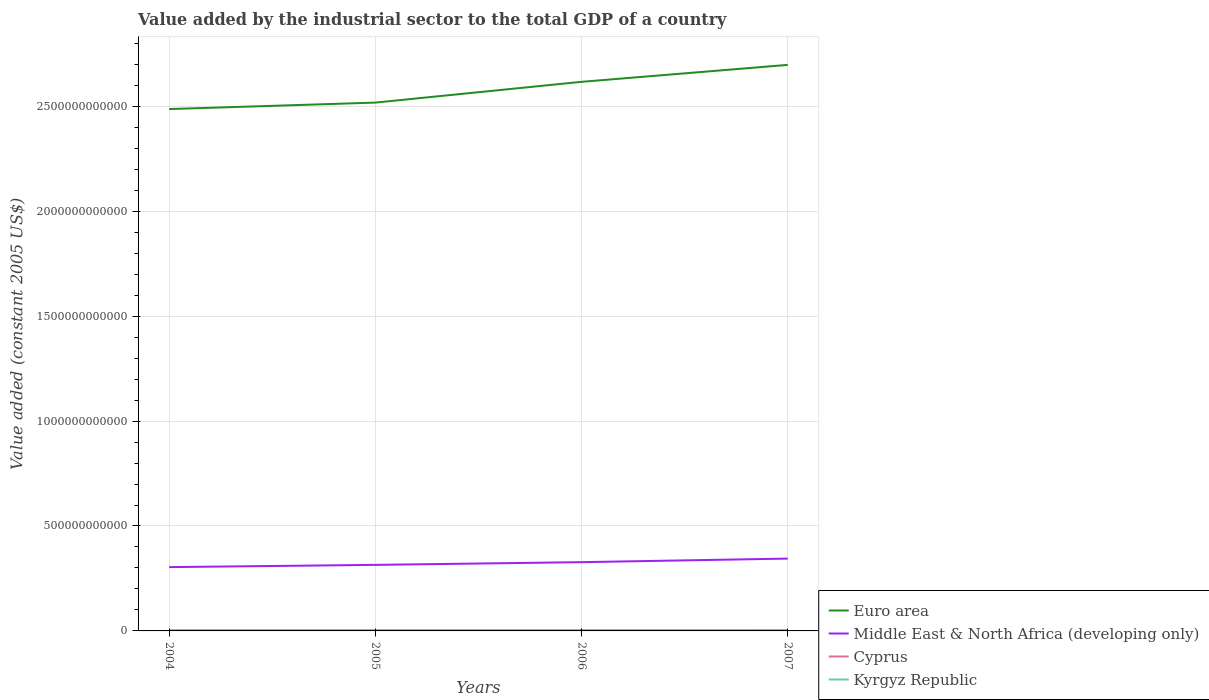Does the line corresponding to Cyprus intersect with the line corresponding to Middle East & North Africa (developing only)?
Your response must be concise. No. Across all years, what is the maximum value added by the industrial sector in Cyprus?
Give a very brief answer. 3.28e+09. What is the total value added by the industrial sector in Kyrgyz Republic in the graph?
Your response must be concise. 8.83e+07. What is the difference between the highest and the second highest value added by the industrial sector in Euro area?
Your answer should be compact. 2.11e+11. What is the difference between the highest and the lowest value added by the industrial sector in Cyprus?
Provide a succinct answer. 2. Is the value added by the industrial sector in Euro area strictly greater than the value added by the industrial sector in Kyrgyz Republic over the years?
Provide a short and direct response. No. How many years are there in the graph?
Ensure brevity in your answer.  4. What is the difference between two consecutive major ticks on the Y-axis?
Offer a terse response. 5.00e+11. Are the values on the major ticks of Y-axis written in scientific E-notation?
Offer a terse response. No. What is the title of the graph?
Provide a succinct answer. Value added by the industrial sector to the total GDP of a country. What is the label or title of the X-axis?
Make the answer very short. Years. What is the label or title of the Y-axis?
Ensure brevity in your answer.  Value added (constant 2005 US$). What is the Value added (constant 2005 US$) of Euro area in 2004?
Offer a terse response. 2.49e+12. What is the Value added (constant 2005 US$) in Middle East & North Africa (developing only) in 2004?
Your response must be concise. 3.04e+11. What is the Value added (constant 2005 US$) of Cyprus in 2004?
Keep it short and to the point. 3.28e+09. What is the Value added (constant 2005 US$) of Kyrgyz Republic in 2004?
Your answer should be very brief. 5.45e+08. What is the Value added (constant 2005 US$) of Euro area in 2005?
Provide a short and direct response. 2.52e+12. What is the Value added (constant 2005 US$) of Middle East & North Africa (developing only) in 2005?
Keep it short and to the point. 3.15e+11. What is the Value added (constant 2005 US$) of Cyprus in 2005?
Make the answer very short. 3.34e+09. What is the Value added (constant 2005 US$) in Kyrgyz Republic in 2005?
Your response must be concise. 4.91e+08. What is the Value added (constant 2005 US$) of Euro area in 2006?
Offer a terse response. 2.62e+12. What is the Value added (constant 2005 US$) of Middle East & North Africa (developing only) in 2006?
Provide a succinct answer. 3.28e+11. What is the Value added (constant 2005 US$) in Cyprus in 2006?
Provide a succinct answer. 3.45e+09. What is the Value added (constant 2005 US$) of Kyrgyz Republic in 2006?
Offer a very short reply. 4.57e+08. What is the Value added (constant 2005 US$) in Euro area in 2007?
Offer a terse response. 2.70e+12. What is the Value added (constant 2005 US$) in Middle East & North Africa (developing only) in 2007?
Your answer should be compact. 3.45e+11. What is the Value added (constant 2005 US$) in Cyprus in 2007?
Offer a very short reply. 3.65e+09. What is the Value added (constant 2005 US$) of Kyrgyz Republic in 2007?
Your response must be concise. 5.04e+08. Across all years, what is the maximum Value added (constant 2005 US$) in Euro area?
Provide a short and direct response. 2.70e+12. Across all years, what is the maximum Value added (constant 2005 US$) of Middle East & North Africa (developing only)?
Give a very brief answer. 3.45e+11. Across all years, what is the maximum Value added (constant 2005 US$) of Cyprus?
Offer a terse response. 3.65e+09. Across all years, what is the maximum Value added (constant 2005 US$) in Kyrgyz Republic?
Your answer should be compact. 5.45e+08. Across all years, what is the minimum Value added (constant 2005 US$) in Euro area?
Your response must be concise. 2.49e+12. Across all years, what is the minimum Value added (constant 2005 US$) of Middle East & North Africa (developing only)?
Ensure brevity in your answer.  3.04e+11. Across all years, what is the minimum Value added (constant 2005 US$) in Cyprus?
Make the answer very short. 3.28e+09. Across all years, what is the minimum Value added (constant 2005 US$) in Kyrgyz Republic?
Offer a very short reply. 4.57e+08. What is the total Value added (constant 2005 US$) of Euro area in the graph?
Make the answer very short. 1.03e+13. What is the total Value added (constant 2005 US$) of Middle East & North Africa (developing only) in the graph?
Keep it short and to the point. 1.29e+12. What is the total Value added (constant 2005 US$) of Cyprus in the graph?
Keep it short and to the point. 1.37e+1. What is the total Value added (constant 2005 US$) of Kyrgyz Republic in the graph?
Make the answer very short. 2.00e+09. What is the difference between the Value added (constant 2005 US$) of Euro area in 2004 and that in 2005?
Ensure brevity in your answer.  -3.10e+1. What is the difference between the Value added (constant 2005 US$) in Middle East & North Africa (developing only) in 2004 and that in 2005?
Provide a short and direct response. -1.07e+1. What is the difference between the Value added (constant 2005 US$) in Cyprus in 2004 and that in 2005?
Make the answer very short. -5.62e+07. What is the difference between the Value added (constant 2005 US$) of Kyrgyz Republic in 2004 and that in 2005?
Offer a terse response. 5.37e+07. What is the difference between the Value added (constant 2005 US$) of Euro area in 2004 and that in 2006?
Offer a very short reply. -1.30e+11. What is the difference between the Value added (constant 2005 US$) in Middle East & North Africa (developing only) in 2004 and that in 2006?
Provide a short and direct response. -2.36e+1. What is the difference between the Value added (constant 2005 US$) of Cyprus in 2004 and that in 2006?
Your answer should be very brief. -1.70e+08. What is the difference between the Value added (constant 2005 US$) in Kyrgyz Republic in 2004 and that in 2006?
Provide a succinct answer. 8.83e+07. What is the difference between the Value added (constant 2005 US$) in Euro area in 2004 and that in 2007?
Offer a terse response. -2.11e+11. What is the difference between the Value added (constant 2005 US$) in Middle East & North Africa (developing only) in 2004 and that in 2007?
Your answer should be compact. -4.06e+1. What is the difference between the Value added (constant 2005 US$) in Cyprus in 2004 and that in 2007?
Give a very brief answer. -3.75e+08. What is the difference between the Value added (constant 2005 US$) in Kyrgyz Republic in 2004 and that in 2007?
Keep it short and to the point. 4.13e+07. What is the difference between the Value added (constant 2005 US$) of Euro area in 2005 and that in 2006?
Your response must be concise. -9.90e+1. What is the difference between the Value added (constant 2005 US$) of Middle East & North Africa (developing only) in 2005 and that in 2006?
Offer a terse response. -1.30e+1. What is the difference between the Value added (constant 2005 US$) in Cyprus in 2005 and that in 2006?
Your answer should be compact. -1.14e+08. What is the difference between the Value added (constant 2005 US$) of Kyrgyz Republic in 2005 and that in 2006?
Provide a succinct answer. 3.46e+07. What is the difference between the Value added (constant 2005 US$) in Euro area in 2005 and that in 2007?
Provide a succinct answer. -1.80e+11. What is the difference between the Value added (constant 2005 US$) of Middle East & North Africa (developing only) in 2005 and that in 2007?
Your response must be concise. -2.99e+1. What is the difference between the Value added (constant 2005 US$) of Cyprus in 2005 and that in 2007?
Provide a succinct answer. -3.19e+08. What is the difference between the Value added (constant 2005 US$) of Kyrgyz Republic in 2005 and that in 2007?
Your answer should be compact. -1.24e+07. What is the difference between the Value added (constant 2005 US$) of Euro area in 2006 and that in 2007?
Your answer should be very brief. -8.08e+1. What is the difference between the Value added (constant 2005 US$) in Middle East & North Africa (developing only) in 2006 and that in 2007?
Give a very brief answer. -1.70e+1. What is the difference between the Value added (constant 2005 US$) in Cyprus in 2006 and that in 2007?
Offer a very short reply. -2.05e+08. What is the difference between the Value added (constant 2005 US$) in Kyrgyz Republic in 2006 and that in 2007?
Make the answer very short. -4.70e+07. What is the difference between the Value added (constant 2005 US$) of Euro area in 2004 and the Value added (constant 2005 US$) of Middle East & North Africa (developing only) in 2005?
Your response must be concise. 2.17e+12. What is the difference between the Value added (constant 2005 US$) in Euro area in 2004 and the Value added (constant 2005 US$) in Cyprus in 2005?
Ensure brevity in your answer.  2.48e+12. What is the difference between the Value added (constant 2005 US$) in Euro area in 2004 and the Value added (constant 2005 US$) in Kyrgyz Republic in 2005?
Offer a very short reply. 2.49e+12. What is the difference between the Value added (constant 2005 US$) of Middle East & North Africa (developing only) in 2004 and the Value added (constant 2005 US$) of Cyprus in 2005?
Your response must be concise. 3.01e+11. What is the difference between the Value added (constant 2005 US$) in Middle East & North Africa (developing only) in 2004 and the Value added (constant 2005 US$) in Kyrgyz Republic in 2005?
Your answer should be compact. 3.04e+11. What is the difference between the Value added (constant 2005 US$) of Cyprus in 2004 and the Value added (constant 2005 US$) of Kyrgyz Republic in 2005?
Provide a short and direct response. 2.79e+09. What is the difference between the Value added (constant 2005 US$) of Euro area in 2004 and the Value added (constant 2005 US$) of Middle East & North Africa (developing only) in 2006?
Offer a terse response. 2.16e+12. What is the difference between the Value added (constant 2005 US$) in Euro area in 2004 and the Value added (constant 2005 US$) in Cyprus in 2006?
Make the answer very short. 2.48e+12. What is the difference between the Value added (constant 2005 US$) of Euro area in 2004 and the Value added (constant 2005 US$) of Kyrgyz Republic in 2006?
Your answer should be very brief. 2.49e+12. What is the difference between the Value added (constant 2005 US$) of Middle East & North Africa (developing only) in 2004 and the Value added (constant 2005 US$) of Cyprus in 2006?
Provide a succinct answer. 3.01e+11. What is the difference between the Value added (constant 2005 US$) of Middle East & North Africa (developing only) in 2004 and the Value added (constant 2005 US$) of Kyrgyz Republic in 2006?
Offer a terse response. 3.04e+11. What is the difference between the Value added (constant 2005 US$) in Cyprus in 2004 and the Value added (constant 2005 US$) in Kyrgyz Republic in 2006?
Your answer should be compact. 2.82e+09. What is the difference between the Value added (constant 2005 US$) in Euro area in 2004 and the Value added (constant 2005 US$) in Middle East & North Africa (developing only) in 2007?
Provide a succinct answer. 2.14e+12. What is the difference between the Value added (constant 2005 US$) of Euro area in 2004 and the Value added (constant 2005 US$) of Cyprus in 2007?
Provide a short and direct response. 2.48e+12. What is the difference between the Value added (constant 2005 US$) of Euro area in 2004 and the Value added (constant 2005 US$) of Kyrgyz Republic in 2007?
Offer a very short reply. 2.49e+12. What is the difference between the Value added (constant 2005 US$) in Middle East & North Africa (developing only) in 2004 and the Value added (constant 2005 US$) in Cyprus in 2007?
Keep it short and to the point. 3.00e+11. What is the difference between the Value added (constant 2005 US$) of Middle East & North Africa (developing only) in 2004 and the Value added (constant 2005 US$) of Kyrgyz Republic in 2007?
Give a very brief answer. 3.04e+11. What is the difference between the Value added (constant 2005 US$) of Cyprus in 2004 and the Value added (constant 2005 US$) of Kyrgyz Republic in 2007?
Your answer should be very brief. 2.78e+09. What is the difference between the Value added (constant 2005 US$) of Euro area in 2005 and the Value added (constant 2005 US$) of Middle East & North Africa (developing only) in 2006?
Provide a succinct answer. 2.19e+12. What is the difference between the Value added (constant 2005 US$) in Euro area in 2005 and the Value added (constant 2005 US$) in Cyprus in 2006?
Your response must be concise. 2.51e+12. What is the difference between the Value added (constant 2005 US$) of Euro area in 2005 and the Value added (constant 2005 US$) of Kyrgyz Republic in 2006?
Ensure brevity in your answer.  2.52e+12. What is the difference between the Value added (constant 2005 US$) of Middle East & North Africa (developing only) in 2005 and the Value added (constant 2005 US$) of Cyprus in 2006?
Offer a terse response. 3.11e+11. What is the difference between the Value added (constant 2005 US$) in Middle East & North Africa (developing only) in 2005 and the Value added (constant 2005 US$) in Kyrgyz Republic in 2006?
Your answer should be compact. 3.14e+11. What is the difference between the Value added (constant 2005 US$) in Cyprus in 2005 and the Value added (constant 2005 US$) in Kyrgyz Republic in 2006?
Provide a short and direct response. 2.88e+09. What is the difference between the Value added (constant 2005 US$) of Euro area in 2005 and the Value added (constant 2005 US$) of Middle East & North Africa (developing only) in 2007?
Provide a succinct answer. 2.17e+12. What is the difference between the Value added (constant 2005 US$) of Euro area in 2005 and the Value added (constant 2005 US$) of Cyprus in 2007?
Offer a very short reply. 2.51e+12. What is the difference between the Value added (constant 2005 US$) in Euro area in 2005 and the Value added (constant 2005 US$) in Kyrgyz Republic in 2007?
Your answer should be compact. 2.52e+12. What is the difference between the Value added (constant 2005 US$) in Middle East & North Africa (developing only) in 2005 and the Value added (constant 2005 US$) in Cyprus in 2007?
Make the answer very short. 3.11e+11. What is the difference between the Value added (constant 2005 US$) in Middle East & North Africa (developing only) in 2005 and the Value added (constant 2005 US$) in Kyrgyz Republic in 2007?
Provide a succinct answer. 3.14e+11. What is the difference between the Value added (constant 2005 US$) of Cyprus in 2005 and the Value added (constant 2005 US$) of Kyrgyz Republic in 2007?
Make the answer very short. 2.83e+09. What is the difference between the Value added (constant 2005 US$) of Euro area in 2006 and the Value added (constant 2005 US$) of Middle East & North Africa (developing only) in 2007?
Your response must be concise. 2.27e+12. What is the difference between the Value added (constant 2005 US$) of Euro area in 2006 and the Value added (constant 2005 US$) of Cyprus in 2007?
Offer a very short reply. 2.61e+12. What is the difference between the Value added (constant 2005 US$) of Euro area in 2006 and the Value added (constant 2005 US$) of Kyrgyz Republic in 2007?
Keep it short and to the point. 2.62e+12. What is the difference between the Value added (constant 2005 US$) in Middle East & North Africa (developing only) in 2006 and the Value added (constant 2005 US$) in Cyprus in 2007?
Give a very brief answer. 3.24e+11. What is the difference between the Value added (constant 2005 US$) in Middle East & North Africa (developing only) in 2006 and the Value added (constant 2005 US$) in Kyrgyz Republic in 2007?
Offer a terse response. 3.27e+11. What is the difference between the Value added (constant 2005 US$) of Cyprus in 2006 and the Value added (constant 2005 US$) of Kyrgyz Republic in 2007?
Provide a succinct answer. 2.95e+09. What is the average Value added (constant 2005 US$) in Euro area per year?
Offer a terse response. 2.58e+12. What is the average Value added (constant 2005 US$) in Middle East & North Africa (developing only) per year?
Give a very brief answer. 3.23e+11. What is the average Value added (constant 2005 US$) of Cyprus per year?
Make the answer very short. 3.43e+09. What is the average Value added (constant 2005 US$) in Kyrgyz Republic per year?
Ensure brevity in your answer.  4.99e+08. In the year 2004, what is the difference between the Value added (constant 2005 US$) in Euro area and Value added (constant 2005 US$) in Middle East & North Africa (developing only)?
Give a very brief answer. 2.18e+12. In the year 2004, what is the difference between the Value added (constant 2005 US$) of Euro area and Value added (constant 2005 US$) of Cyprus?
Offer a very short reply. 2.48e+12. In the year 2004, what is the difference between the Value added (constant 2005 US$) of Euro area and Value added (constant 2005 US$) of Kyrgyz Republic?
Ensure brevity in your answer.  2.49e+12. In the year 2004, what is the difference between the Value added (constant 2005 US$) of Middle East & North Africa (developing only) and Value added (constant 2005 US$) of Cyprus?
Your answer should be very brief. 3.01e+11. In the year 2004, what is the difference between the Value added (constant 2005 US$) in Middle East & North Africa (developing only) and Value added (constant 2005 US$) in Kyrgyz Republic?
Your answer should be very brief. 3.04e+11. In the year 2004, what is the difference between the Value added (constant 2005 US$) of Cyprus and Value added (constant 2005 US$) of Kyrgyz Republic?
Ensure brevity in your answer.  2.73e+09. In the year 2005, what is the difference between the Value added (constant 2005 US$) in Euro area and Value added (constant 2005 US$) in Middle East & North Africa (developing only)?
Offer a terse response. 2.20e+12. In the year 2005, what is the difference between the Value added (constant 2005 US$) of Euro area and Value added (constant 2005 US$) of Cyprus?
Make the answer very short. 2.51e+12. In the year 2005, what is the difference between the Value added (constant 2005 US$) of Euro area and Value added (constant 2005 US$) of Kyrgyz Republic?
Your answer should be compact. 2.52e+12. In the year 2005, what is the difference between the Value added (constant 2005 US$) in Middle East & North Africa (developing only) and Value added (constant 2005 US$) in Cyprus?
Provide a short and direct response. 3.11e+11. In the year 2005, what is the difference between the Value added (constant 2005 US$) of Middle East & North Africa (developing only) and Value added (constant 2005 US$) of Kyrgyz Republic?
Provide a succinct answer. 3.14e+11. In the year 2005, what is the difference between the Value added (constant 2005 US$) in Cyprus and Value added (constant 2005 US$) in Kyrgyz Republic?
Your answer should be very brief. 2.84e+09. In the year 2006, what is the difference between the Value added (constant 2005 US$) of Euro area and Value added (constant 2005 US$) of Middle East & North Africa (developing only)?
Your response must be concise. 2.29e+12. In the year 2006, what is the difference between the Value added (constant 2005 US$) of Euro area and Value added (constant 2005 US$) of Cyprus?
Provide a succinct answer. 2.61e+12. In the year 2006, what is the difference between the Value added (constant 2005 US$) of Euro area and Value added (constant 2005 US$) of Kyrgyz Republic?
Keep it short and to the point. 2.62e+12. In the year 2006, what is the difference between the Value added (constant 2005 US$) in Middle East & North Africa (developing only) and Value added (constant 2005 US$) in Cyprus?
Make the answer very short. 3.24e+11. In the year 2006, what is the difference between the Value added (constant 2005 US$) in Middle East & North Africa (developing only) and Value added (constant 2005 US$) in Kyrgyz Republic?
Keep it short and to the point. 3.27e+11. In the year 2006, what is the difference between the Value added (constant 2005 US$) of Cyprus and Value added (constant 2005 US$) of Kyrgyz Republic?
Your answer should be very brief. 2.99e+09. In the year 2007, what is the difference between the Value added (constant 2005 US$) in Euro area and Value added (constant 2005 US$) in Middle East & North Africa (developing only)?
Your answer should be compact. 2.35e+12. In the year 2007, what is the difference between the Value added (constant 2005 US$) of Euro area and Value added (constant 2005 US$) of Cyprus?
Give a very brief answer. 2.69e+12. In the year 2007, what is the difference between the Value added (constant 2005 US$) in Euro area and Value added (constant 2005 US$) in Kyrgyz Republic?
Your response must be concise. 2.70e+12. In the year 2007, what is the difference between the Value added (constant 2005 US$) in Middle East & North Africa (developing only) and Value added (constant 2005 US$) in Cyprus?
Offer a terse response. 3.41e+11. In the year 2007, what is the difference between the Value added (constant 2005 US$) of Middle East & North Africa (developing only) and Value added (constant 2005 US$) of Kyrgyz Republic?
Provide a succinct answer. 3.44e+11. In the year 2007, what is the difference between the Value added (constant 2005 US$) in Cyprus and Value added (constant 2005 US$) in Kyrgyz Republic?
Give a very brief answer. 3.15e+09. What is the ratio of the Value added (constant 2005 US$) of Euro area in 2004 to that in 2005?
Make the answer very short. 0.99. What is the ratio of the Value added (constant 2005 US$) in Middle East & North Africa (developing only) in 2004 to that in 2005?
Ensure brevity in your answer.  0.97. What is the ratio of the Value added (constant 2005 US$) of Cyprus in 2004 to that in 2005?
Your answer should be compact. 0.98. What is the ratio of the Value added (constant 2005 US$) in Kyrgyz Republic in 2004 to that in 2005?
Ensure brevity in your answer.  1.11. What is the ratio of the Value added (constant 2005 US$) of Euro area in 2004 to that in 2006?
Your answer should be compact. 0.95. What is the ratio of the Value added (constant 2005 US$) in Middle East & North Africa (developing only) in 2004 to that in 2006?
Give a very brief answer. 0.93. What is the ratio of the Value added (constant 2005 US$) in Cyprus in 2004 to that in 2006?
Give a very brief answer. 0.95. What is the ratio of the Value added (constant 2005 US$) in Kyrgyz Republic in 2004 to that in 2006?
Offer a very short reply. 1.19. What is the ratio of the Value added (constant 2005 US$) in Euro area in 2004 to that in 2007?
Your answer should be compact. 0.92. What is the ratio of the Value added (constant 2005 US$) in Middle East & North Africa (developing only) in 2004 to that in 2007?
Give a very brief answer. 0.88. What is the ratio of the Value added (constant 2005 US$) of Cyprus in 2004 to that in 2007?
Ensure brevity in your answer.  0.9. What is the ratio of the Value added (constant 2005 US$) of Kyrgyz Republic in 2004 to that in 2007?
Your answer should be very brief. 1.08. What is the ratio of the Value added (constant 2005 US$) in Euro area in 2005 to that in 2006?
Give a very brief answer. 0.96. What is the ratio of the Value added (constant 2005 US$) in Middle East & North Africa (developing only) in 2005 to that in 2006?
Your answer should be very brief. 0.96. What is the ratio of the Value added (constant 2005 US$) of Cyprus in 2005 to that in 2006?
Make the answer very short. 0.97. What is the ratio of the Value added (constant 2005 US$) in Kyrgyz Republic in 2005 to that in 2006?
Give a very brief answer. 1.08. What is the ratio of the Value added (constant 2005 US$) of Euro area in 2005 to that in 2007?
Your answer should be compact. 0.93. What is the ratio of the Value added (constant 2005 US$) of Middle East & North Africa (developing only) in 2005 to that in 2007?
Keep it short and to the point. 0.91. What is the ratio of the Value added (constant 2005 US$) in Cyprus in 2005 to that in 2007?
Ensure brevity in your answer.  0.91. What is the ratio of the Value added (constant 2005 US$) of Kyrgyz Republic in 2005 to that in 2007?
Offer a very short reply. 0.98. What is the ratio of the Value added (constant 2005 US$) in Euro area in 2006 to that in 2007?
Your answer should be compact. 0.97. What is the ratio of the Value added (constant 2005 US$) in Middle East & North Africa (developing only) in 2006 to that in 2007?
Provide a short and direct response. 0.95. What is the ratio of the Value added (constant 2005 US$) in Cyprus in 2006 to that in 2007?
Make the answer very short. 0.94. What is the ratio of the Value added (constant 2005 US$) of Kyrgyz Republic in 2006 to that in 2007?
Your response must be concise. 0.91. What is the difference between the highest and the second highest Value added (constant 2005 US$) of Euro area?
Keep it short and to the point. 8.08e+1. What is the difference between the highest and the second highest Value added (constant 2005 US$) of Middle East & North Africa (developing only)?
Your response must be concise. 1.70e+1. What is the difference between the highest and the second highest Value added (constant 2005 US$) in Cyprus?
Ensure brevity in your answer.  2.05e+08. What is the difference between the highest and the second highest Value added (constant 2005 US$) in Kyrgyz Republic?
Ensure brevity in your answer.  4.13e+07. What is the difference between the highest and the lowest Value added (constant 2005 US$) in Euro area?
Your answer should be compact. 2.11e+11. What is the difference between the highest and the lowest Value added (constant 2005 US$) in Middle East & North Africa (developing only)?
Provide a short and direct response. 4.06e+1. What is the difference between the highest and the lowest Value added (constant 2005 US$) in Cyprus?
Provide a short and direct response. 3.75e+08. What is the difference between the highest and the lowest Value added (constant 2005 US$) of Kyrgyz Republic?
Offer a very short reply. 8.83e+07. 